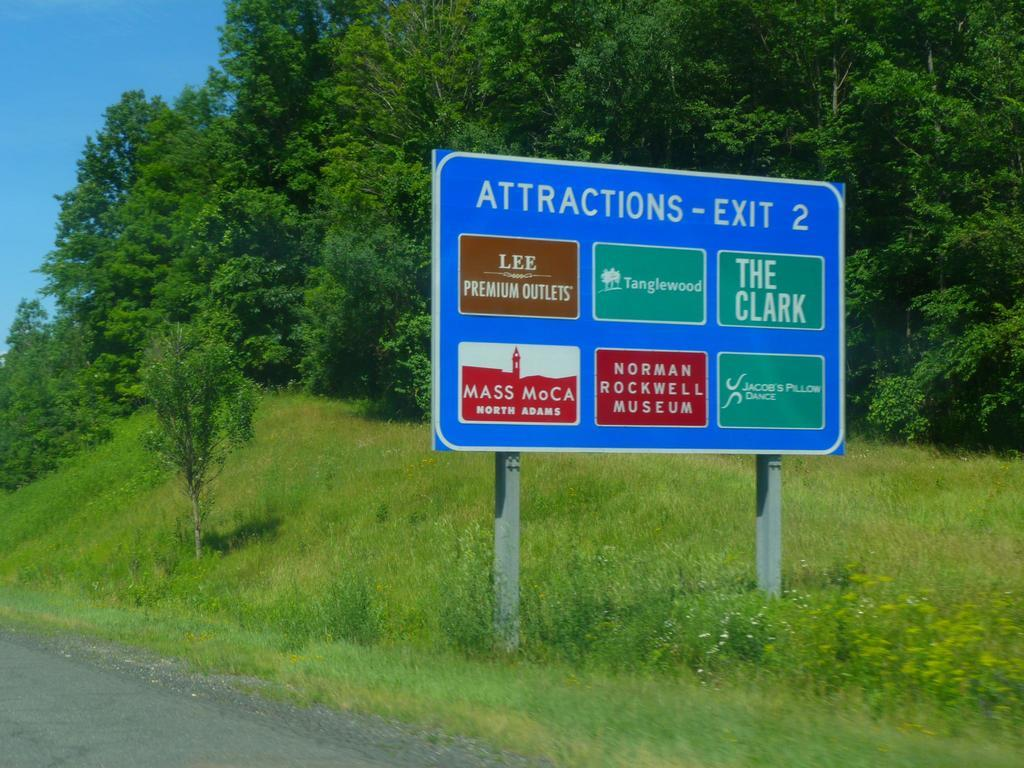What type of surface can be seen in the image? There is a road in the image. What type of vegetation is present in the image? There is grass in the image. What object can be seen in the foreground of the image? There is a board in the image. What is located behind the board in the image? There are trees behind the board. What is the condition of the sky in the image? The sky is clear in the image. How many pears are hanging from the trees in the image? There are no pears visible in the image; only trees are present. What type of women can be seen walking on the road in the image? There are no women present in the image; only a road, grass, a board, trees, and the sky are visible. 